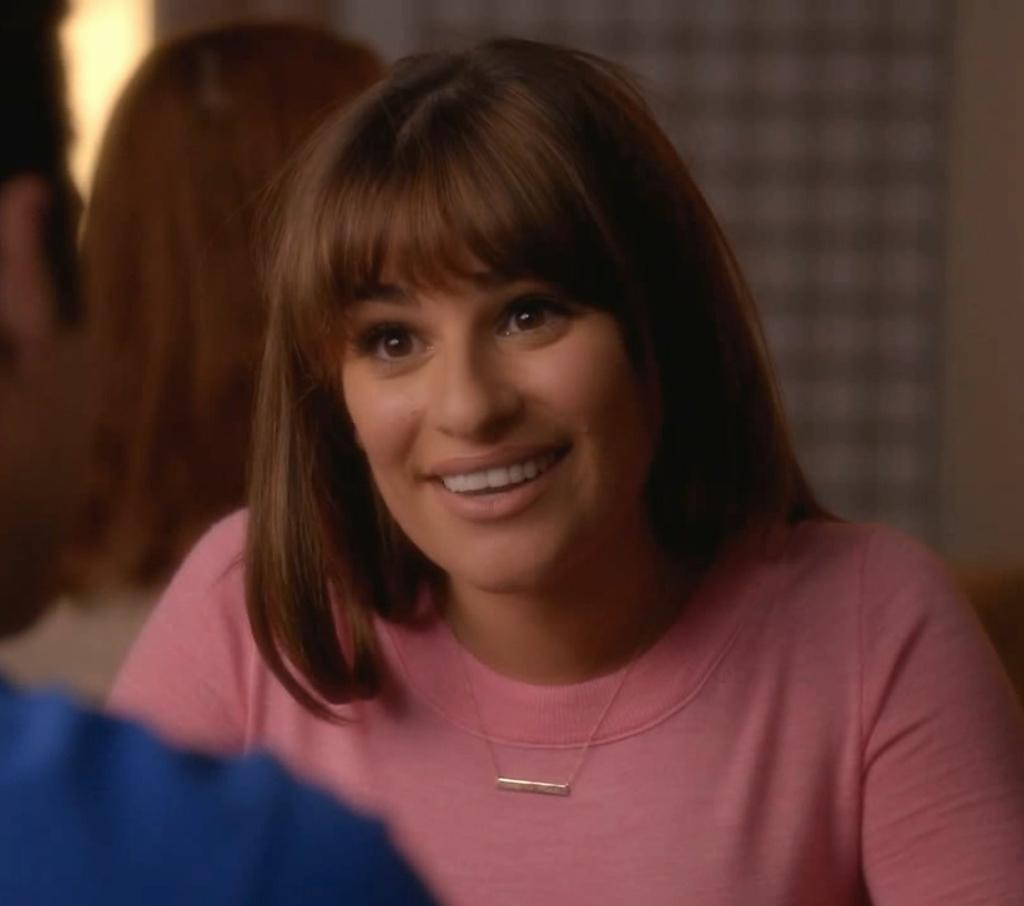What can be observed about the background of the image? The background portion of the picture is blurred. Who is present in the image? There is a woman in the picture. What is the woman's expression in the image? The woman is smiling. Can you describe any other person in the image? There is a partial part of a man on the left side of the picture. What does the fly say in the caption of the image? There is no fly or caption present in the image. What is on the top of the woman's head in the image? The image does not show anything on the top of the woman's head. 